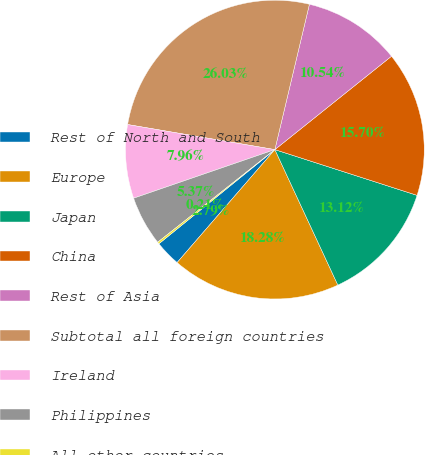<chart> <loc_0><loc_0><loc_500><loc_500><pie_chart><fcel>Rest of North and South<fcel>Europe<fcel>Japan<fcel>China<fcel>Rest of Asia<fcel>Subtotal all foreign countries<fcel>Ireland<fcel>Philippines<fcel>All other countries<nl><fcel>2.79%<fcel>18.28%<fcel>13.12%<fcel>15.7%<fcel>10.54%<fcel>26.03%<fcel>7.96%<fcel>5.37%<fcel>0.21%<nl></chart> 